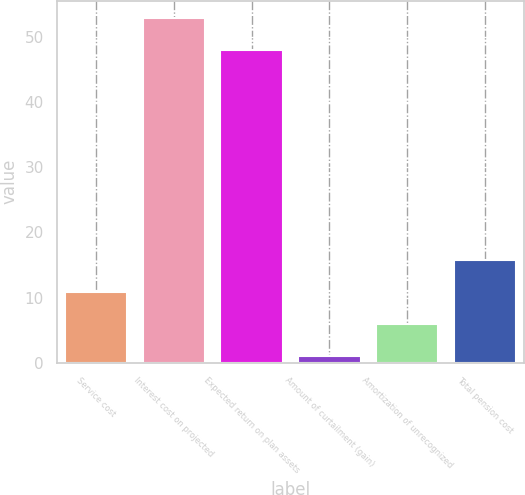Convert chart. <chart><loc_0><loc_0><loc_500><loc_500><bar_chart><fcel>Service cost<fcel>Interest cost on projected<fcel>Expected return on plan assets<fcel>Amount of curtailment (gain)<fcel>Amortization of unrecognized<fcel>Total pension cost<nl><fcel>10.8<fcel>52.9<fcel>48<fcel>1<fcel>5.9<fcel>15.7<nl></chart> 